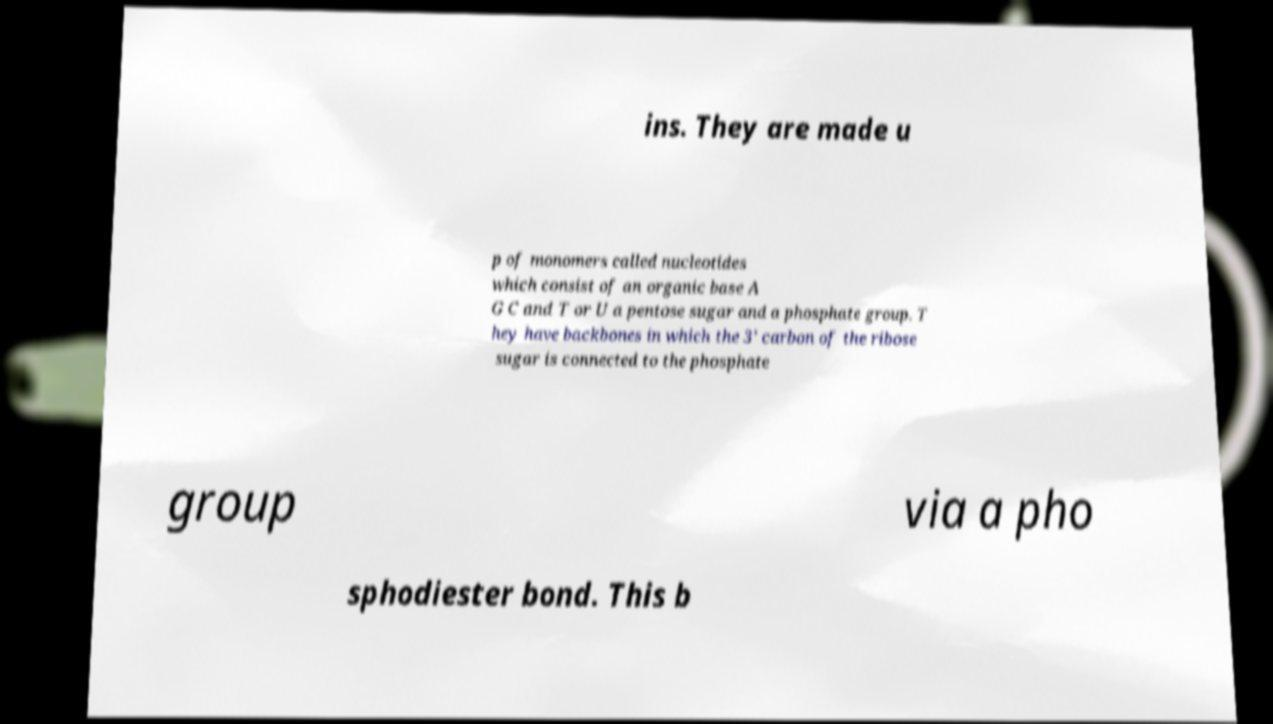I need the written content from this picture converted into text. Can you do that? ins. They are made u p of monomers called nucleotides which consist of an organic base A G C and T or U a pentose sugar and a phosphate group. T hey have backbones in which the 3’ carbon of the ribose sugar is connected to the phosphate group via a pho sphodiester bond. This b 